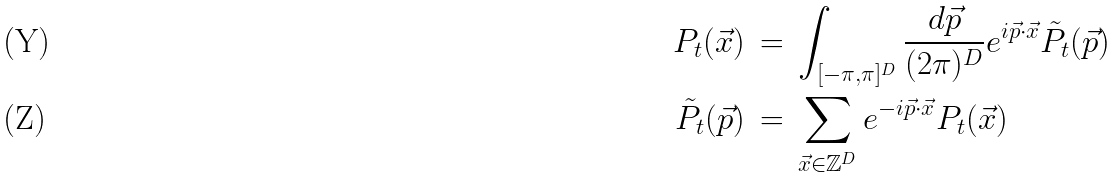Convert formula to latex. <formula><loc_0><loc_0><loc_500><loc_500>P _ { t } ( \vec { x } ) & \, = \, \int _ { [ - \pi , \pi ] ^ { D } } \frac { d \vec { p } } { ( 2 \pi ) ^ { D } } e ^ { i \vec { p } \cdot \vec { x } } \tilde { P } _ { t } ( \vec { p } ) \\ \tilde { P } _ { t } ( \vec { p } ) & \, = \, \sum _ { \vec { x } \in { \mathbb { Z } } ^ { D } } e ^ { - i \vec { p } \cdot \vec { x } } P _ { t } ( \vec { x } )</formula> 